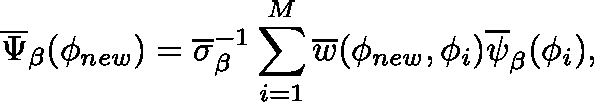Convert formula to latex. <formula><loc_0><loc_0><loc_500><loc_500>\overline { \Psi } _ { \beta } ( \phi _ { n e w } ) = \overline { \sigma } _ { \beta } ^ { - 1 } \sum _ { i = 1 } ^ { M } \overline { w } ( \phi _ { n e w } , \phi _ { i } ) \overline { \psi } _ { \beta } ( \phi _ { i } ) ,</formula> 